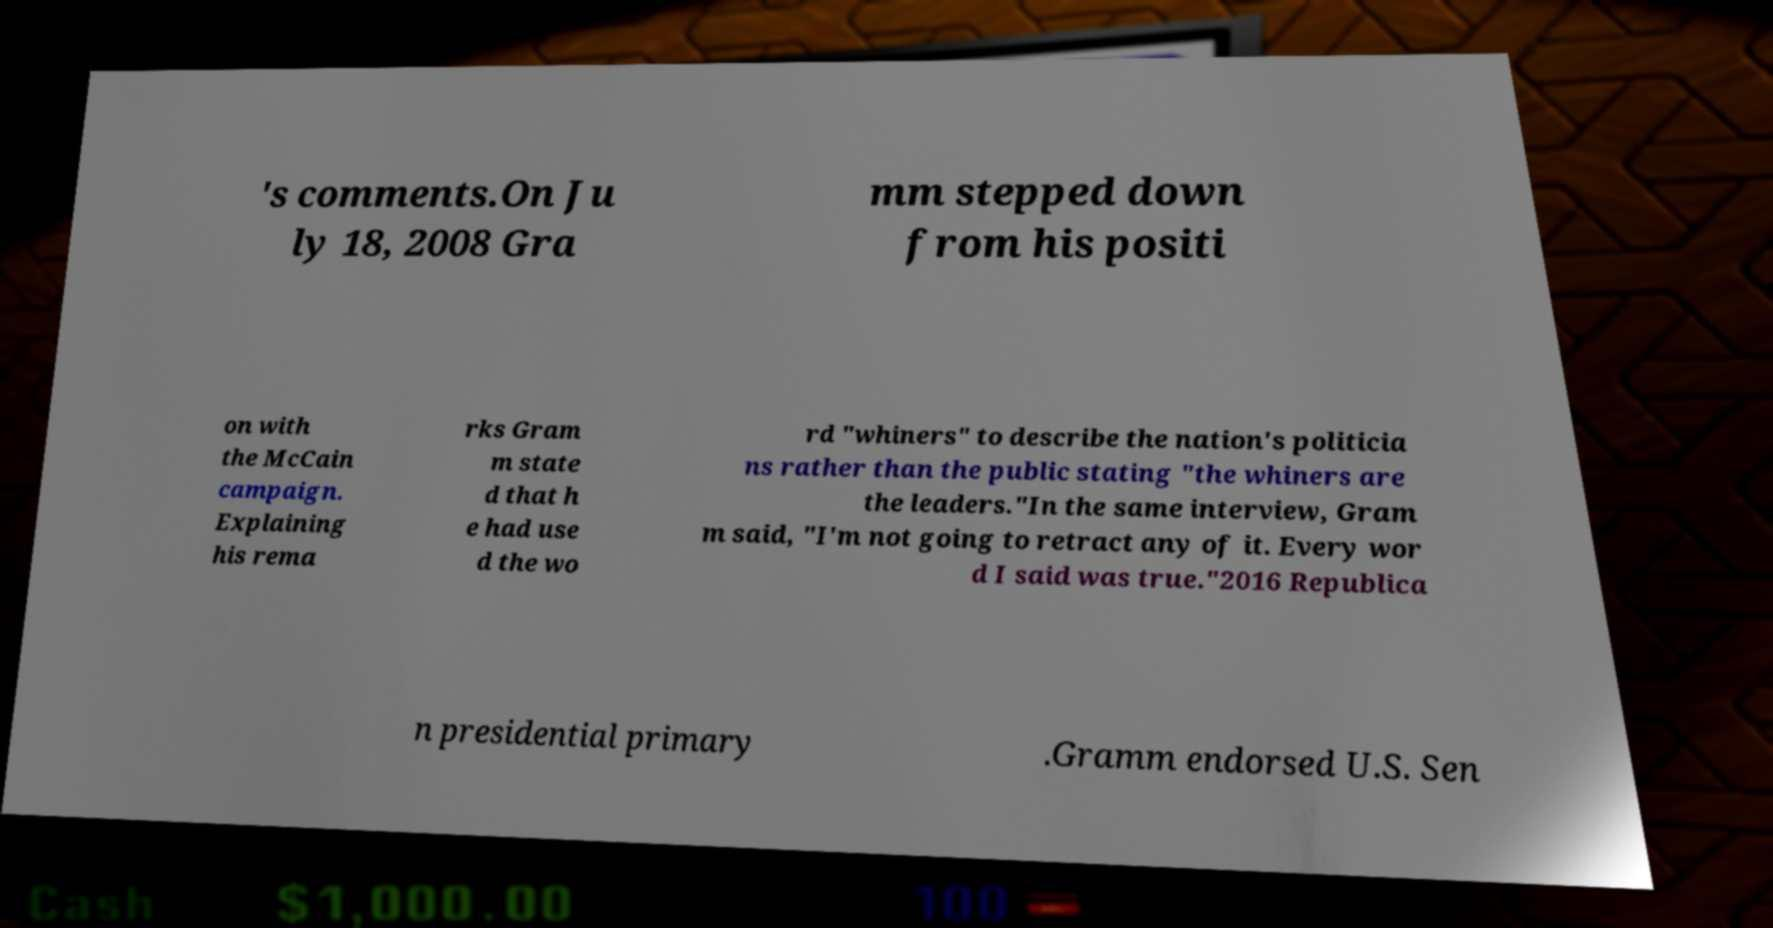Can you read and provide the text displayed in the image?This photo seems to have some interesting text. Can you extract and type it out for me? 's comments.On Ju ly 18, 2008 Gra mm stepped down from his positi on with the McCain campaign. Explaining his rema rks Gram m state d that h e had use d the wo rd "whiners" to describe the nation's politicia ns rather than the public stating "the whiners are the leaders."In the same interview, Gram m said, "I'm not going to retract any of it. Every wor d I said was true."2016 Republica n presidential primary .Gramm endorsed U.S. Sen 